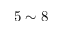Convert formula to latex. <formula><loc_0><loc_0><loc_500><loc_500>5 \sim 8</formula> 